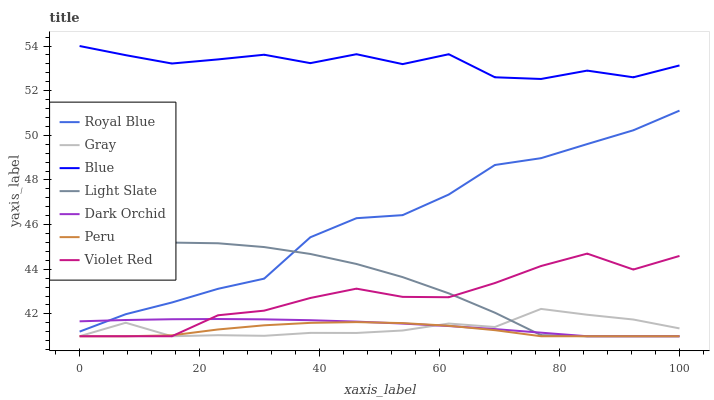Does Gray have the minimum area under the curve?
Answer yes or no. No. Does Gray have the maximum area under the curve?
Answer yes or no. No. Is Gray the smoothest?
Answer yes or no. No. Is Gray the roughest?
Answer yes or no. No. Does Royal Blue have the lowest value?
Answer yes or no. No. Does Gray have the highest value?
Answer yes or no. No. Is Dark Orchid less than Blue?
Answer yes or no. Yes. Is Blue greater than Dark Orchid?
Answer yes or no. Yes. Does Dark Orchid intersect Blue?
Answer yes or no. No. 